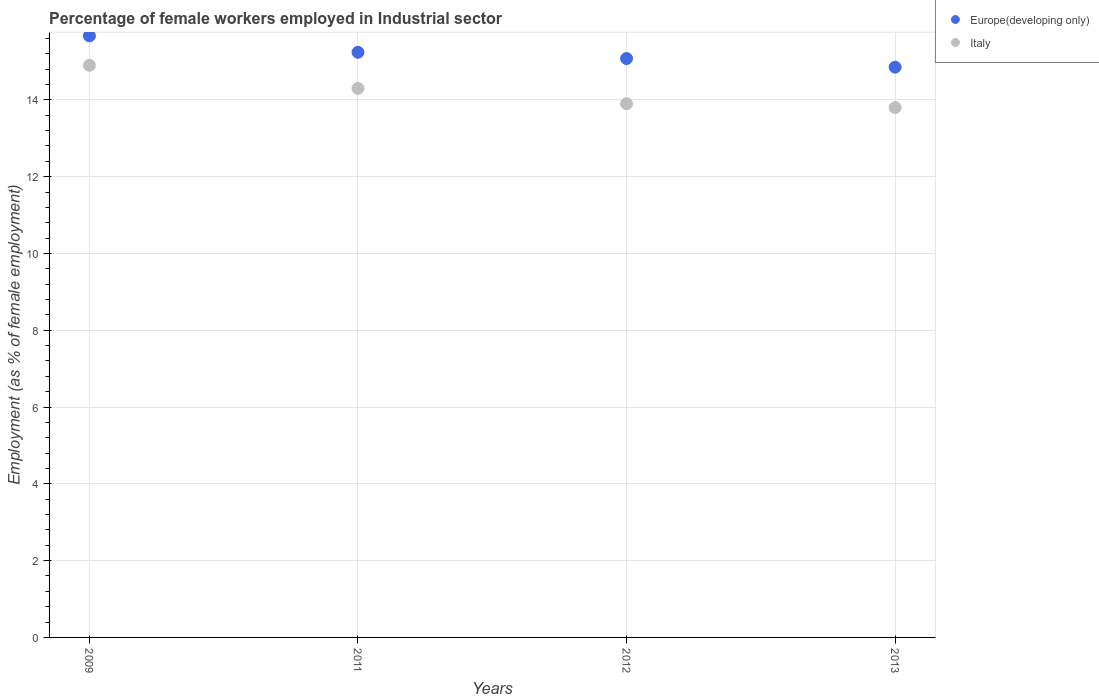How many different coloured dotlines are there?
Keep it short and to the point. 2. Is the number of dotlines equal to the number of legend labels?
Keep it short and to the point. Yes. What is the percentage of females employed in Industrial sector in Europe(developing only) in 2009?
Provide a succinct answer. 15.67. Across all years, what is the maximum percentage of females employed in Industrial sector in Italy?
Your answer should be very brief. 14.9. Across all years, what is the minimum percentage of females employed in Industrial sector in Europe(developing only)?
Make the answer very short. 14.85. In which year was the percentage of females employed in Industrial sector in Europe(developing only) minimum?
Your answer should be very brief. 2013. What is the total percentage of females employed in Industrial sector in Italy in the graph?
Offer a very short reply. 56.9. What is the difference between the percentage of females employed in Industrial sector in Italy in 2011 and that in 2012?
Make the answer very short. 0.4. What is the difference between the percentage of females employed in Industrial sector in Italy in 2009 and the percentage of females employed in Industrial sector in Europe(developing only) in 2012?
Provide a short and direct response. -0.18. What is the average percentage of females employed in Industrial sector in Europe(developing only) per year?
Provide a succinct answer. 15.21. In the year 2012, what is the difference between the percentage of females employed in Industrial sector in Europe(developing only) and percentage of females employed in Industrial sector in Italy?
Provide a succinct answer. 1.18. What is the ratio of the percentage of females employed in Industrial sector in Europe(developing only) in 2011 to that in 2013?
Provide a short and direct response. 1.03. Is the difference between the percentage of females employed in Industrial sector in Europe(developing only) in 2011 and 2012 greater than the difference between the percentage of females employed in Industrial sector in Italy in 2011 and 2012?
Give a very brief answer. No. What is the difference between the highest and the second highest percentage of females employed in Industrial sector in Italy?
Offer a terse response. 0.6. What is the difference between the highest and the lowest percentage of females employed in Industrial sector in Europe(developing only)?
Keep it short and to the point. 0.82. In how many years, is the percentage of females employed in Industrial sector in Italy greater than the average percentage of females employed in Industrial sector in Italy taken over all years?
Keep it short and to the point. 2. Does the percentage of females employed in Industrial sector in Italy monotonically increase over the years?
Provide a short and direct response. No. Is the percentage of females employed in Industrial sector in Italy strictly greater than the percentage of females employed in Industrial sector in Europe(developing only) over the years?
Provide a short and direct response. No. How many years are there in the graph?
Provide a short and direct response. 4. What is the difference between two consecutive major ticks on the Y-axis?
Offer a very short reply. 2. How many legend labels are there?
Ensure brevity in your answer.  2. How are the legend labels stacked?
Give a very brief answer. Vertical. What is the title of the graph?
Your answer should be compact. Percentage of female workers employed in Industrial sector. Does "East Asia (developing only)" appear as one of the legend labels in the graph?
Give a very brief answer. No. What is the label or title of the Y-axis?
Provide a succinct answer. Employment (as % of female employment). What is the Employment (as % of female employment) of Europe(developing only) in 2009?
Give a very brief answer. 15.67. What is the Employment (as % of female employment) in Italy in 2009?
Ensure brevity in your answer.  14.9. What is the Employment (as % of female employment) in Europe(developing only) in 2011?
Your answer should be compact. 15.24. What is the Employment (as % of female employment) of Italy in 2011?
Ensure brevity in your answer.  14.3. What is the Employment (as % of female employment) of Europe(developing only) in 2012?
Give a very brief answer. 15.08. What is the Employment (as % of female employment) of Italy in 2012?
Your answer should be compact. 13.9. What is the Employment (as % of female employment) of Europe(developing only) in 2013?
Give a very brief answer. 14.85. What is the Employment (as % of female employment) in Italy in 2013?
Your answer should be very brief. 13.8. Across all years, what is the maximum Employment (as % of female employment) in Europe(developing only)?
Offer a terse response. 15.67. Across all years, what is the maximum Employment (as % of female employment) in Italy?
Ensure brevity in your answer.  14.9. Across all years, what is the minimum Employment (as % of female employment) of Europe(developing only)?
Offer a very short reply. 14.85. Across all years, what is the minimum Employment (as % of female employment) of Italy?
Your answer should be compact. 13.8. What is the total Employment (as % of female employment) of Europe(developing only) in the graph?
Make the answer very short. 60.84. What is the total Employment (as % of female employment) of Italy in the graph?
Give a very brief answer. 56.9. What is the difference between the Employment (as % of female employment) in Europe(developing only) in 2009 and that in 2011?
Give a very brief answer. 0.43. What is the difference between the Employment (as % of female employment) of Italy in 2009 and that in 2011?
Ensure brevity in your answer.  0.6. What is the difference between the Employment (as % of female employment) in Europe(developing only) in 2009 and that in 2012?
Keep it short and to the point. 0.59. What is the difference between the Employment (as % of female employment) in Europe(developing only) in 2009 and that in 2013?
Offer a very short reply. 0.82. What is the difference between the Employment (as % of female employment) of Italy in 2009 and that in 2013?
Your answer should be compact. 1.1. What is the difference between the Employment (as % of female employment) in Europe(developing only) in 2011 and that in 2012?
Make the answer very short. 0.16. What is the difference between the Employment (as % of female employment) in Italy in 2011 and that in 2012?
Ensure brevity in your answer.  0.4. What is the difference between the Employment (as % of female employment) of Europe(developing only) in 2011 and that in 2013?
Offer a terse response. 0.39. What is the difference between the Employment (as % of female employment) of Europe(developing only) in 2012 and that in 2013?
Keep it short and to the point. 0.23. What is the difference between the Employment (as % of female employment) of Italy in 2012 and that in 2013?
Give a very brief answer. 0.1. What is the difference between the Employment (as % of female employment) of Europe(developing only) in 2009 and the Employment (as % of female employment) of Italy in 2011?
Offer a terse response. 1.37. What is the difference between the Employment (as % of female employment) in Europe(developing only) in 2009 and the Employment (as % of female employment) in Italy in 2012?
Your answer should be compact. 1.77. What is the difference between the Employment (as % of female employment) in Europe(developing only) in 2009 and the Employment (as % of female employment) in Italy in 2013?
Ensure brevity in your answer.  1.87. What is the difference between the Employment (as % of female employment) of Europe(developing only) in 2011 and the Employment (as % of female employment) of Italy in 2012?
Provide a short and direct response. 1.34. What is the difference between the Employment (as % of female employment) in Europe(developing only) in 2011 and the Employment (as % of female employment) in Italy in 2013?
Offer a very short reply. 1.44. What is the difference between the Employment (as % of female employment) in Europe(developing only) in 2012 and the Employment (as % of female employment) in Italy in 2013?
Give a very brief answer. 1.28. What is the average Employment (as % of female employment) of Europe(developing only) per year?
Offer a very short reply. 15.21. What is the average Employment (as % of female employment) in Italy per year?
Your response must be concise. 14.22. In the year 2009, what is the difference between the Employment (as % of female employment) in Europe(developing only) and Employment (as % of female employment) in Italy?
Your answer should be very brief. 0.77. In the year 2011, what is the difference between the Employment (as % of female employment) in Europe(developing only) and Employment (as % of female employment) in Italy?
Your response must be concise. 0.94. In the year 2012, what is the difference between the Employment (as % of female employment) in Europe(developing only) and Employment (as % of female employment) in Italy?
Give a very brief answer. 1.18. In the year 2013, what is the difference between the Employment (as % of female employment) of Europe(developing only) and Employment (as % of female employment) of Italy?
Your answer should be very brief. 1.05. What is the ratio of the Employment (as % of female employment) in Europe(developing only) in 2009 to that in 2011?
Offer a very short reply. 1.03. What is the ratio of the Employment (as % of female employment) of Italy in 2009 to that in 2011?
Give a very brief answer. 1.04. What is the ratio of the Employment (as % of female employment) in Europe(developing only) in 2009 to that in 2012?
Offer a very short reply. 1.04. What is the ratio of the Employment (as % of female employment) in Italy in 2009 to that in 2012?
Provide a succinct answer. 1.07. What is the ratio of the Employment (as % of female employment) of Europe(developing only) in 2009 to that in 2013?
Keep it short and to the point. 1.05. What is the ratio of the Employment (as % of female employment) of Italy in 2009 to that in 2013?
Your answer should be very brief. 1.08. What is the ratio of the Employment (as % of female employment) in Europe(developing only) in 2011 to that in 2012?
Your response must be concise. 1.01. What is the ratio of the Employment (as % of female employment) of Italy in 2011 to that in 2012?
Your response must be concise. 1.03. What is the ratio of the Employment (as % of female employment) of Europe(developing only) in 2011 to that in 2013?
Give a very brief answer. 1.03. What is the ratio of the Employment (as % of female employment) of Italy in 2011 to that in 2013?
Provide a short and direct response. 1.04. What is the ratio of the Employment (as % of female employment) of Europe(developing only) in 2012 to that in 2013?
Your answer should be very brief. 1.02. What is the ratio of the Employment (as % of female employment) in Italy in 2012 to that in 2013?
Your response must be concise. 1.01. What is the difference between the highest and the second highest Employment (as % of female employment) in Europe(developing only)?
Ensure brevity in your answer.  0.43. What is the difference between the highest and the lowest Employment (as % of female employment) of Europe(developing only)?
Keep it short and to the point. 0.82. What is the difference between the highest and the lowest Employment (as % of female employment) of Italy?
Provide a succinct answer. 1.1. 